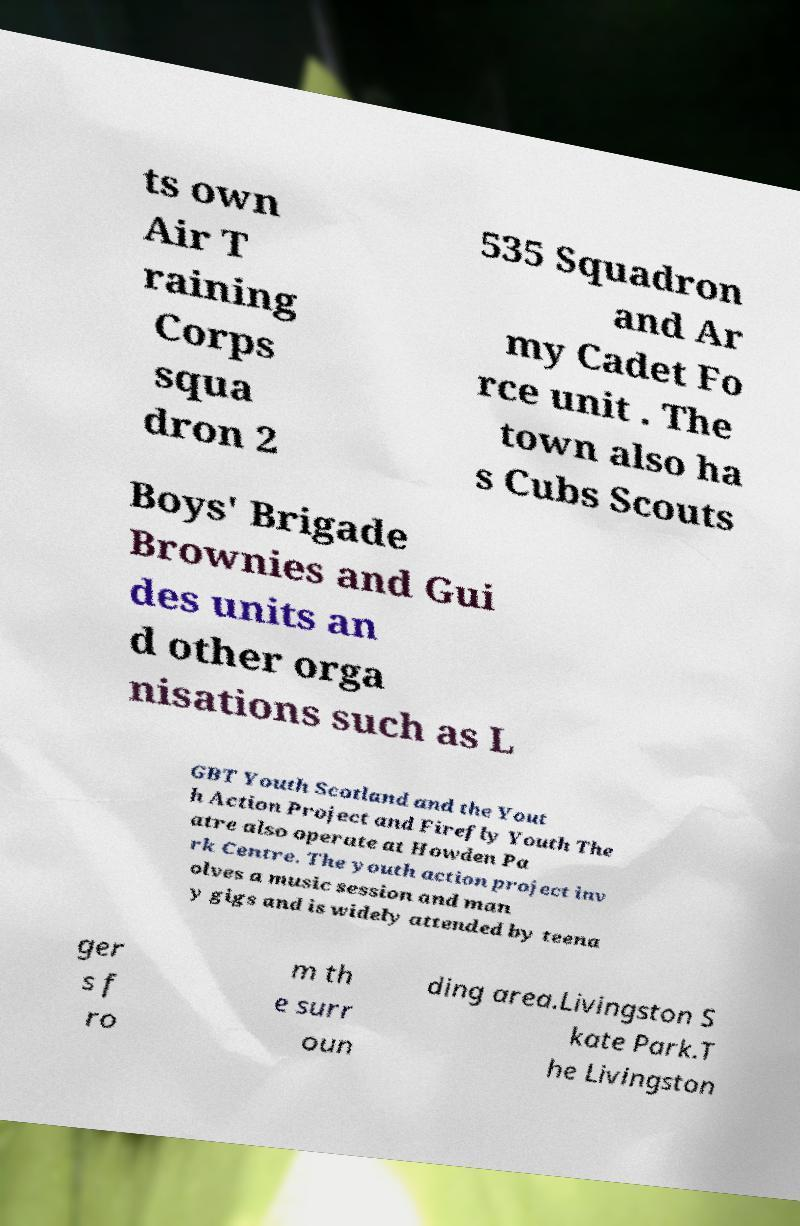Please identify and transcribe the text found in this image. ts own Air T raining Corps squa dron 2 535 Squadron and Ar my Cadet Fo rce unit . The town also ha s Cubs Scouts Boys' Brigade Brownies and Gui des units an d other orga nisations such as L GBT Youth Scotland and the Yout h Action Project and Firefly Youth The atre also operate at Howden Pa rk Centre. The youth action project inv olves a music session and man y gigs and is widely attended by teena ger s f ro m th e surr oun ding area.Livingston S kate Park.T he Livingston 